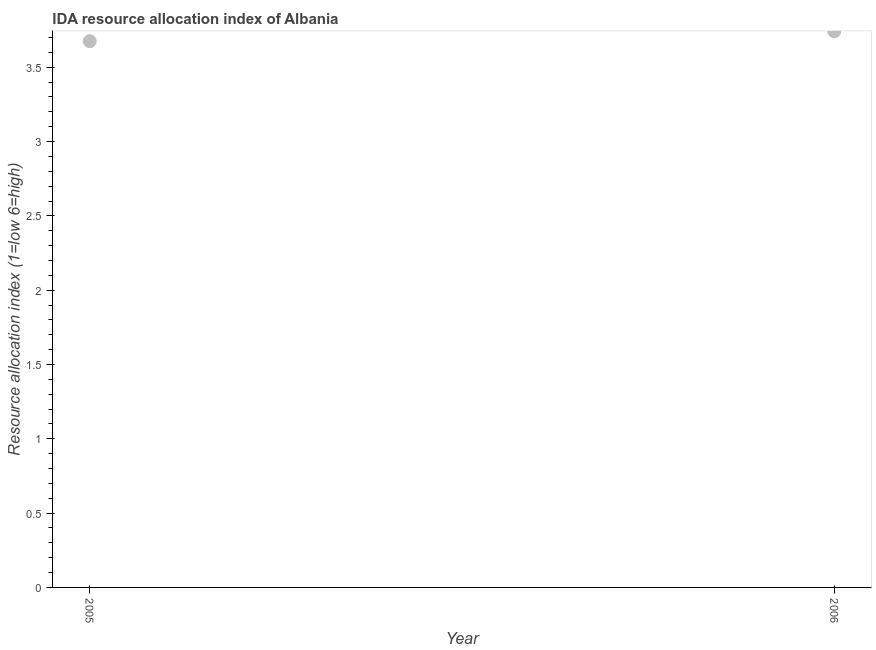What is the ida resource allocation index in 2006?
Your answer should be compact. 3.74. Across all years, what is the maximum ida resource allocation index?
Your answer should be compact. 3.74. Across all years, what is the minimum ida resource allocation index?
Your answer should be very brief. 3.67. In which year was the ida resource allocation index minimum?
Provide a succinct answer. 2005. What is the sum of the ida resource allocation index?
Give a very brief answer. 7.42. What is the difference between the ida resource allocation index in 2005 and 2006?
Offer a very short reply. -0.07. What is the average ida resource allocation index per year?
Give a very brief answer. 3.71. What is the median ida resource allocation index?
Your answer should be compact. 3.71. In how many years, is the ida resource allocation index greater than 1.4 ?
Your response must be concise. 2. What is the ratio of the ida resource allocation index in 2005 to that in 2006?
Keep it short and to the point. 0.98. Is the ida resource allocation index in 2005 less than that in 2006?
Give a very brief answer. Yes. In how many years, is the ida resource allocation index greater than the average ida resource allocation index taken over all years?
Ensure brevity in your answer.  1. How many dotlines are there?
Offer a very short reply. 1. How many years are there in the graph?
Your answer should be very brief. 2. What is the difference between two consecutive major ticks on the Y-axis?
Make the answer very short. 0.5. Are the values on the major ticks of Y-axis written in scientific E-notation?
Make the answer very short. No. Does the graph contain grids?
Provide a short and direct response. No. What is the title of the graph?
Your answer should be very brief. IDA resource allocation index of Albania. What is the label or title of the X-axis?
Make the answer very short. Year. What is the label or title of the Y-axis?
Your answer should be compact. Resource allocation index (1=low 6=high). What is the Resource allocation index (1=low 6=high) in 2005?
Ensure brevity in your answer.  3.67. What is the Resource allocation index (1=low 6=high) in 2006?
Give a very brief answer. 3.74. What is the difference between the Resource allocation index (1=low 6=high) in 2005 and 2006?
Offer a terse response. -0.07. 